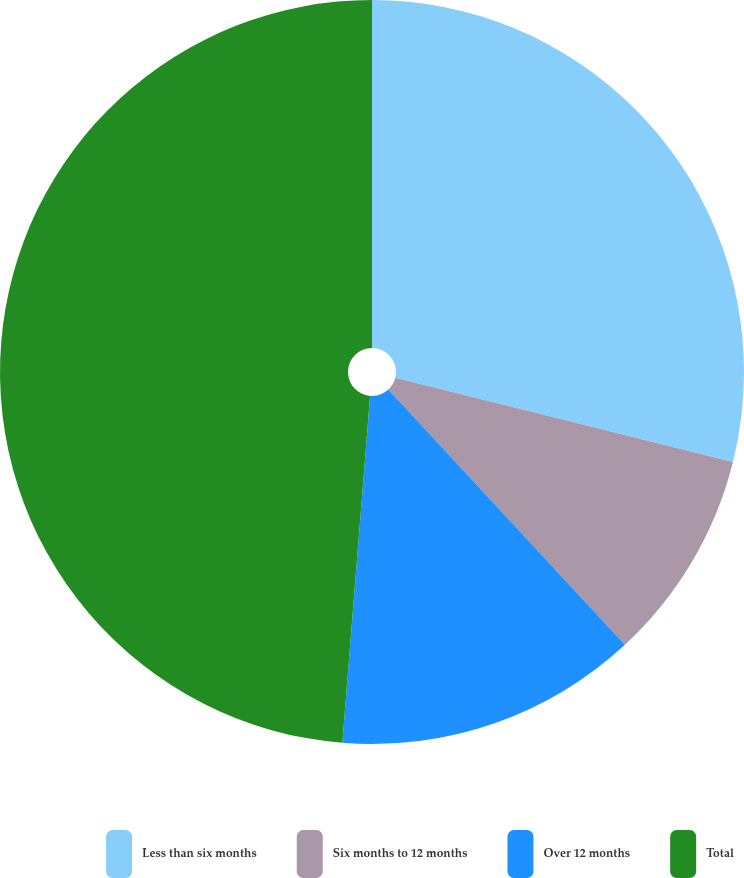<chart> <loc_0><loc_0><loc_500><loc_500><pie_chart><fcel>Less than six months<fcel>Six months to 12 months<fcel>Over 12 months<fcel>Total<nl><fcel>28.89%<fcel>9.21%<fcel>13.17%<fcel>48.73%<nl></chart> 